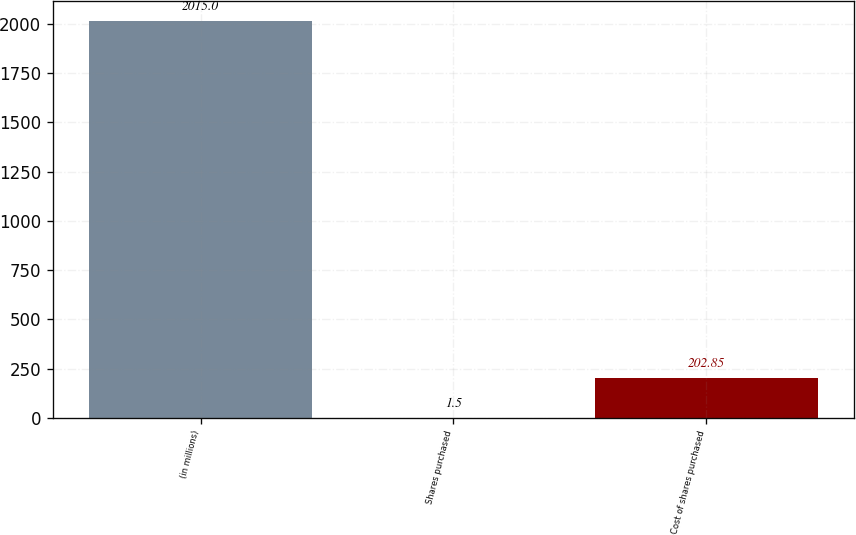Convert chart to OTSL. <chart><loc_0><loc_0><loc_500><loc_500><bar_chart><fcel>(in millions)<fcel>Shares purchased<fcel>Cost of shares purchased<nl><fcel>2015<fcel>1.5<fcel>202.85<nl></chart> 